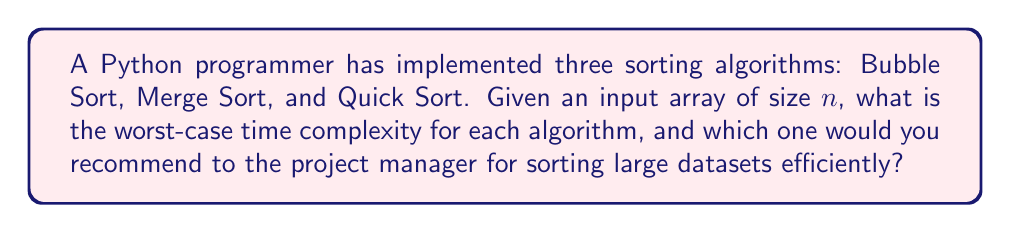Show me your answer to this math problem. Let's analyze the time complexity of each sorting algorithm:

1. Bubble Sort:
   - In the worst case, Bubble Sort makes $n-1$ passes through the array.
   - In each pass, it performs up to $n-1$ comparisons and swaps.
   - Total operations: $(n-1) \times (n-1) = n^2 - 2n + 1$
   - Worst-case time complexity: $O(n^2)$

2. Merge Sort:
   - Merge Sort uses a divide-and-conquer approach.
   - It recursively divides the array into two halves until reaching single elements.
   - The merge step takes $O(n)$ time for each level of recursion.
   - There are $\log_2 n$ levels of recursion.
   - Total time: $n \times \log_2 n$
   - Worst-case time complexity: $O(n \log n)$

3. Quick Sort:
   - In the average case, Quick Sort has a time complexity of $O(n \log n)$.
   - However, in the worst case (when the pivot is always the smallest or largest element):
     - There are $n$ levels of recursion.
     - Each level processes $n, n-1, n-2, ..., 2, 1$ elements.
     - Total operations: $\frac{n(n+1)}{2}$
   - Worst-case time complexity: $O(n^2)$

Comparing the worst-case time complexities:
- Bubble Sort: $O(n^2)$
- Merge Sort: $O(n \log n)$
- Quick Sort: $O(n^2)$

For large datasets, Merge Sort would be the most efficient choice in terms of worst-case time complexity. It consistently performs at $O(n \log n)$, which is significantly better than $O(n^2)$ for large $n$. While Quick Sort has the same average-case complexity as Merge Sort, its worst-case performance can be problematic for large datasets.

Therefore, the recommendation to the project manager would be to use Merge Sort for sorting large datasets efficiently, as it provides consistent performance regardless of the input data's initial order.
Answer: Merge Sort with $O(n \log n)$ worst-case time complexity 